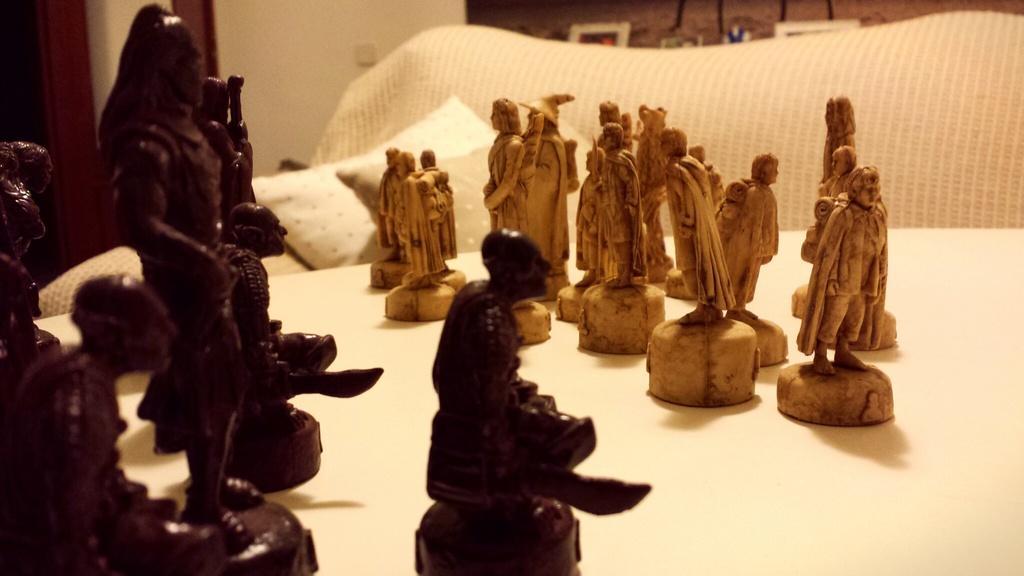In one or two sentences, can you explain what this image depicts? In this picture we can see status on a platform. In the background we can see a wall and there is a pillow. 